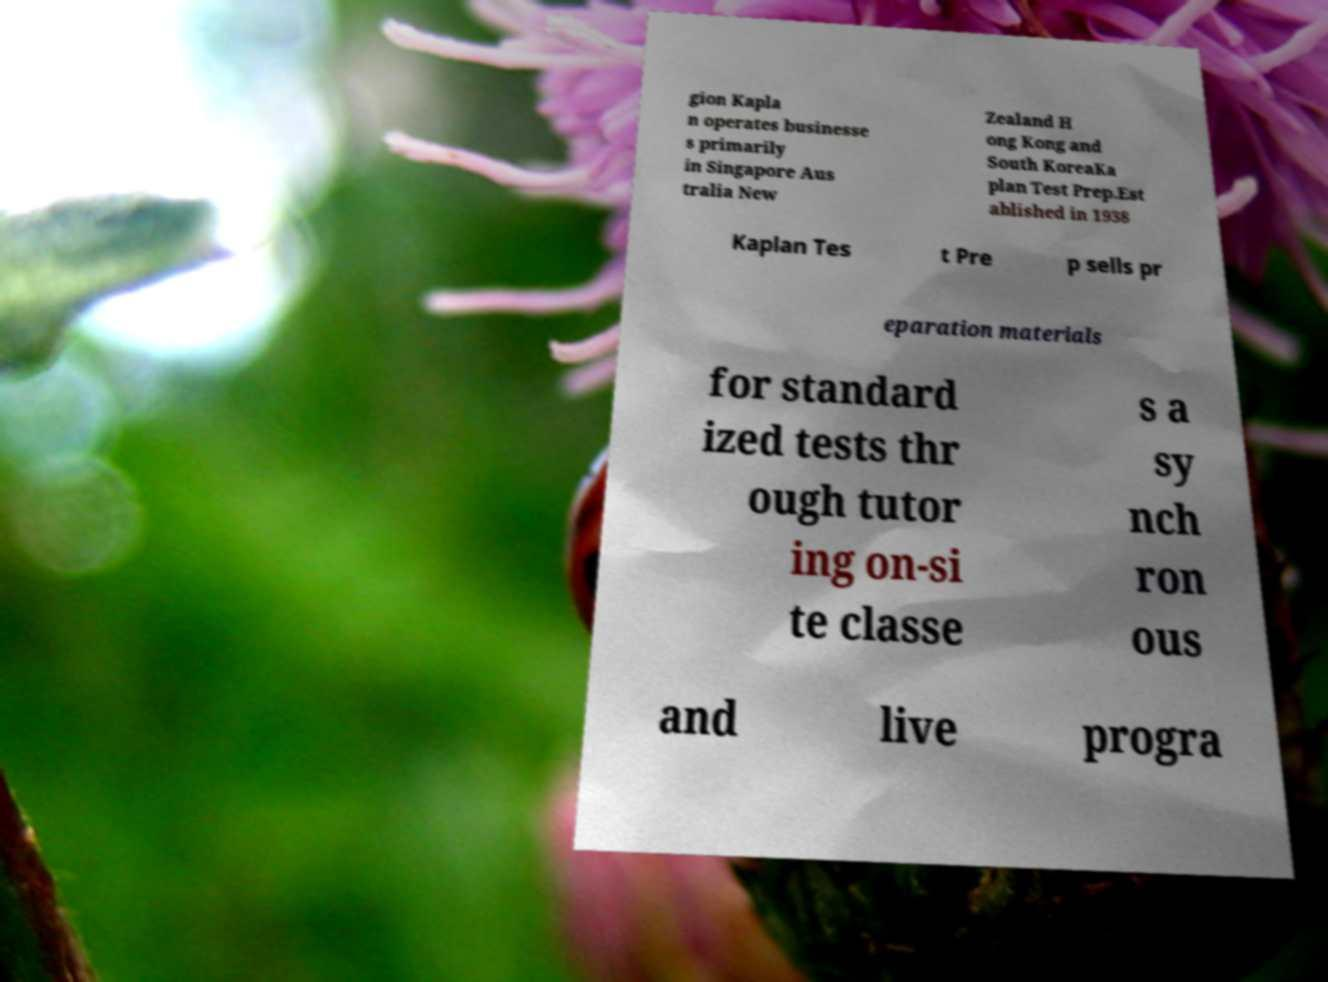Can you accurately transcribe the text from the provided image for me? gion Kapla n operates businesse s primarily in Singapore Aus tralia New Zealand H ong Kong and South KoreaKa plan Test Prep.Est ablished in 1938 Kaplan Tes t Pre p sells pr eparation materials for standard ized tests thr ough tutor ing on-si te classe s a sy nch ron ous and live progra 